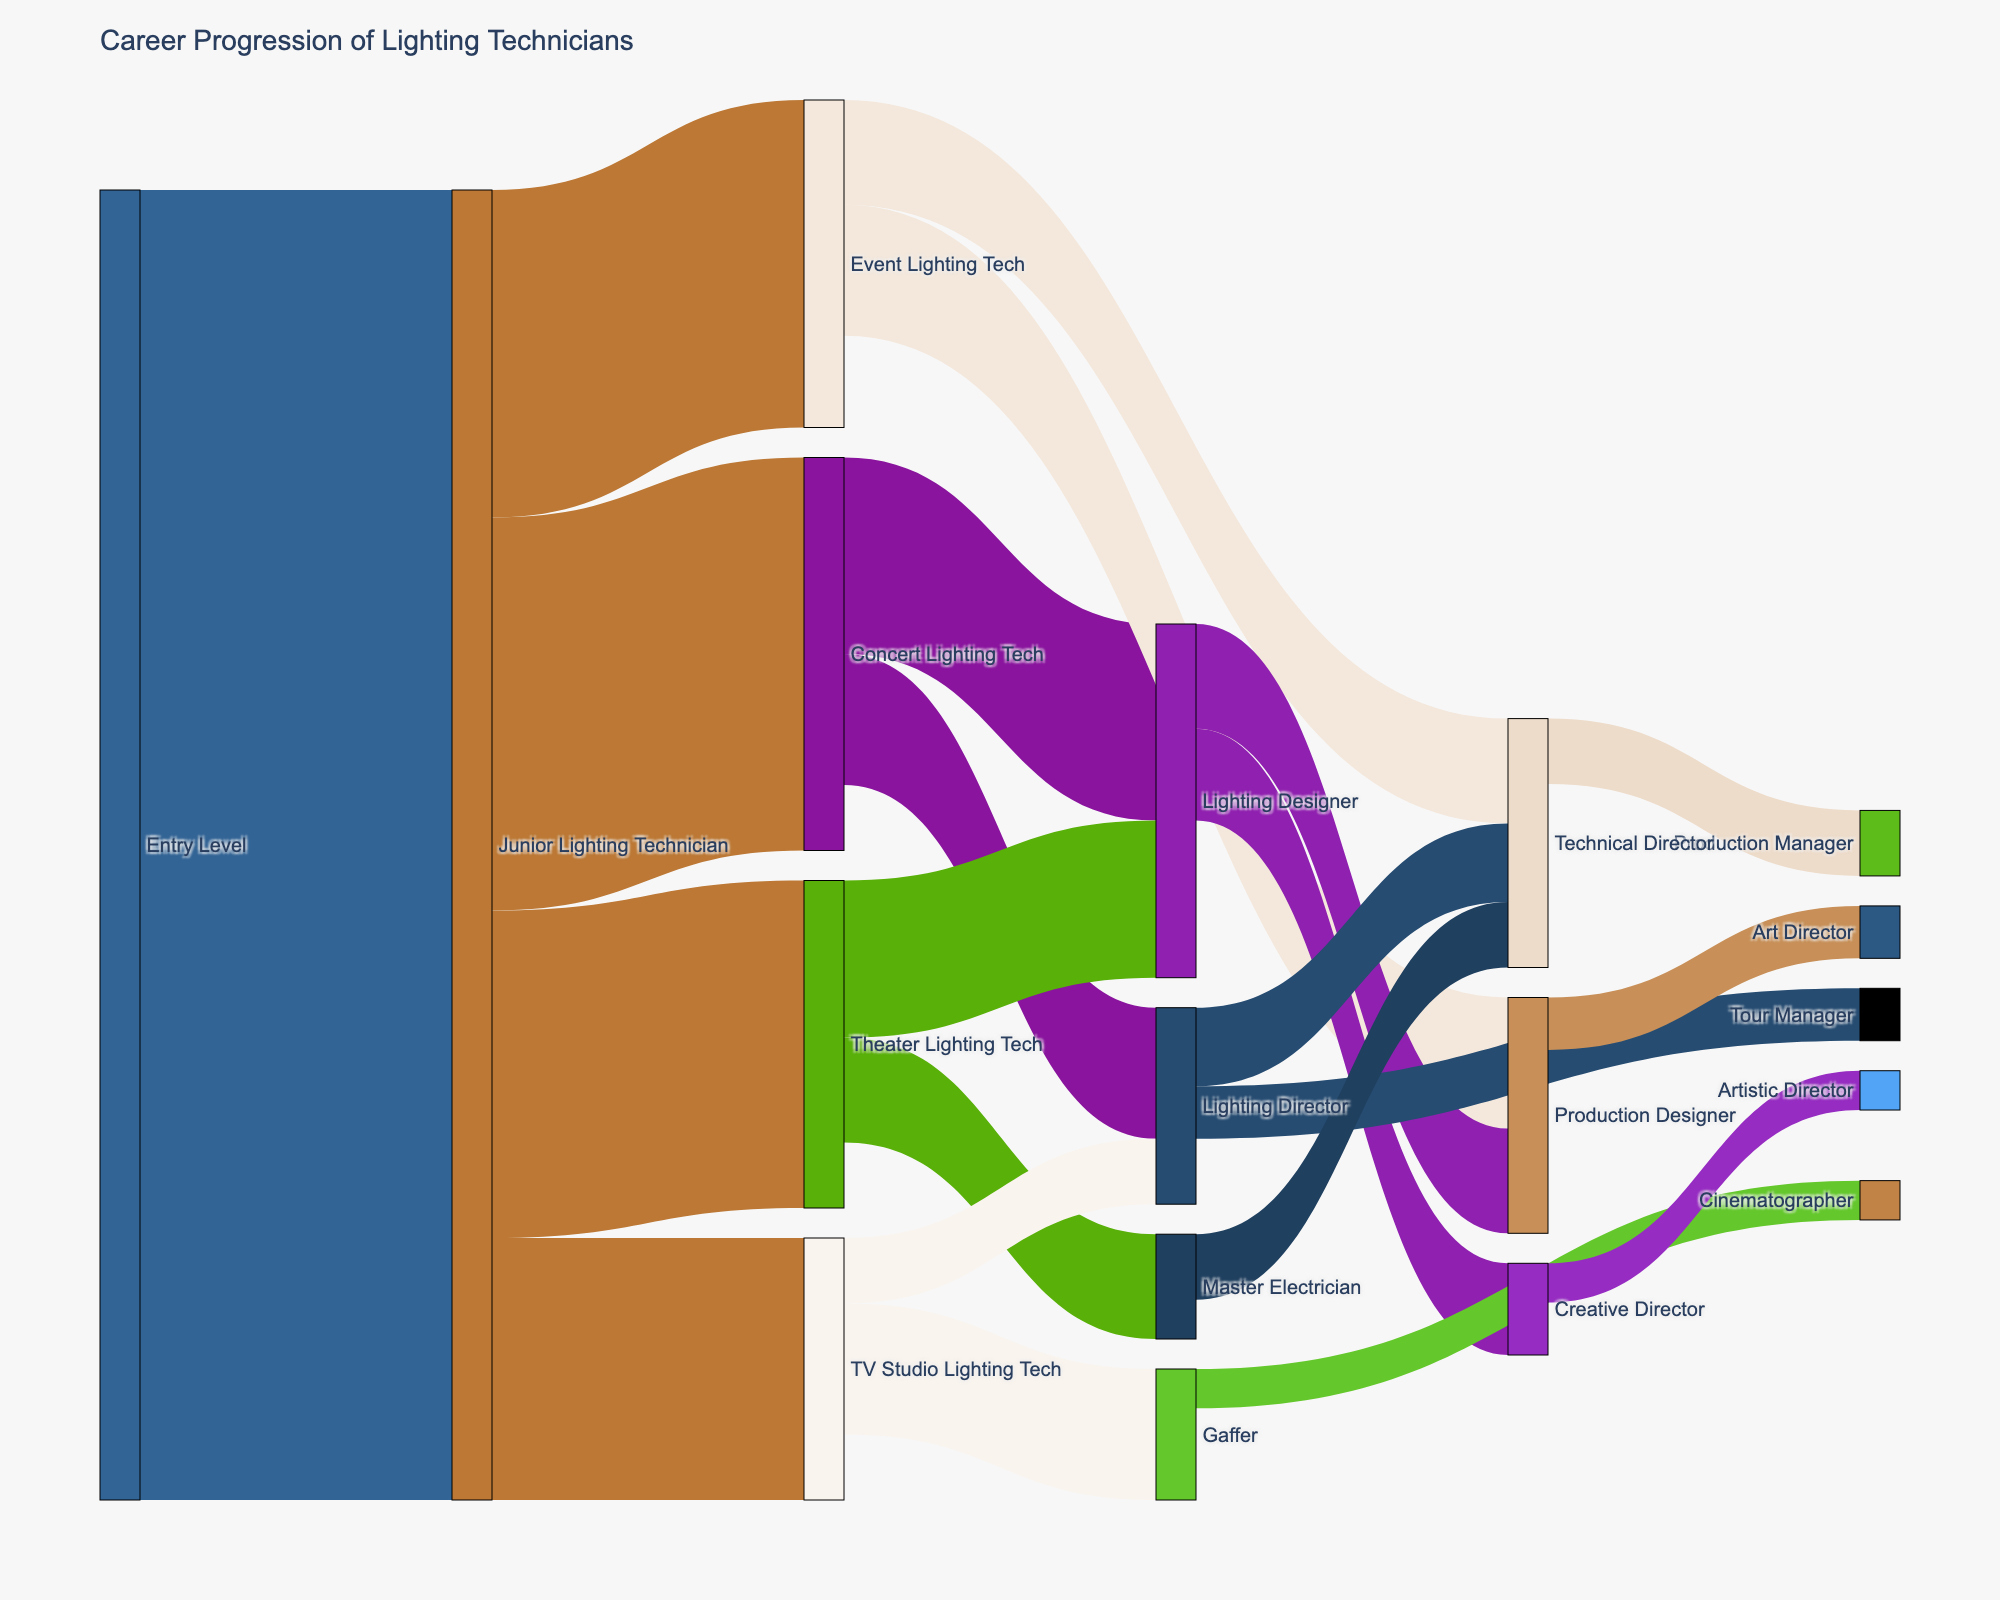What is the starting point for career progression in this diagram? The starting point for career progression is typically shown at the leftmost side of a Sankey diagram. In this case, it is "Entry Level".
Answer: Entry Level How many lighting technicians progressed from Junior Lighting Technician to TV Studio Lighting Tech? The number of lighting technicians moving from one role to another is represented by the link value in a Sankey diagram. Here, the link value from Junior Lighting Technician to TV Studio Lighting Tech is 20.
Answer: 20 Which career path has the highest number of transitions from Junior Lighting Technician? To find the career path with the highest number of transitions from Junior Lighting Technician, we look at the link values from this node. The highest value is 30 to Concert Lighting Tech.
Answer: Concert Lighting Tech What is the final highest-ranking position shown in the diagram? The highest-ranking position is typically the one with the fewest subsequent connections, often found at the far right. "Artistic Director" is such a position with no further transitions.
Answer: Artistic Director How many lighting technicians progressed to the role of Technical Director from different paths? We need to sum the link values leading to the "Technical Director" node. The values are 8 (from Event Lighting Tech), 6 (from Lighting Director), and 5 (from Master Electrician). Therefore, 8 + 6 + 5 = 19.
Answer: 19 Which career step has the most diverse subsequent specialization paths from Junior Lighting Technician? The diversity of subsequent paths can be assessed by counting how many different target nodes a source node connects to. "Junior Lighting Technician" has four different specializations it feeds into: Concert Lighting Tech, Theater Lighting Tech, TV Studio Lighting Tech, and Event Lighting Tech.
Answer: Junior Lighting Technician How many lighting technicians ultimately progressed to becoming Lighting Designers? To find the total number of people who became Lighting Designers, sum up the link values ending at "Lighting Designer": 15 (from Concert Lighting Tech) and 12 (from Theater Lighting Tech). Thus, the total is 15 + 12 = 27.
Answer: 27 What proportion of Entry Level technicians ultimately aim for a Creative Director position? First, find the total number of Entry Level technicians. Then, track the number of those who eventually end up as Creative Directors. Here, from Junior Lighting Technician to Lighting Designer to Creative Director, there are 7. Check the total: 100 at Entry Level. Proportion = 7 / 100.
Answer: 7/100 Which role has the least transitions from Junior Lighting Technician? By comparing link values from Junior Lighting Technician to other roles, the lowest value is for "TV Studio Lighting Tech" with 20.
Answer: TV Studio Lighting Tech 